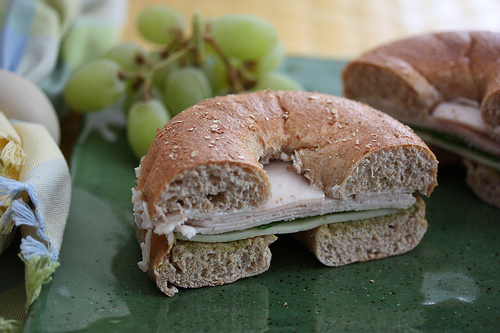<image>
Is the turkey on the bagel? No. The turkey is not positioned on the bagel. They may be near each other, but the turkey is not supported by or resting on top of the bagel. 